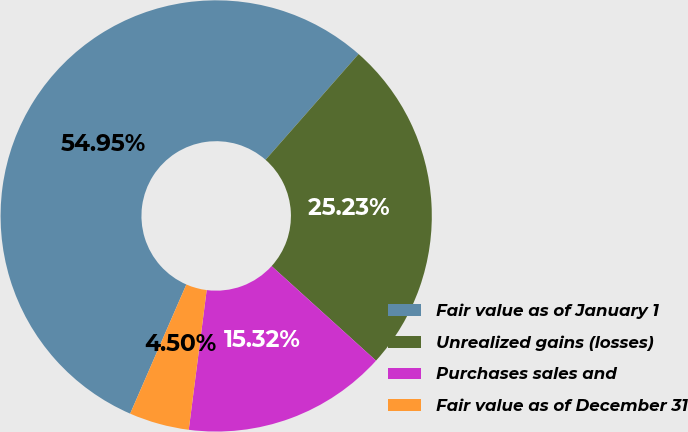<chart> <loc_0><loc_0><loc_500><loc_500><pie_chart><fcel>Fair value as of January 1<fcel>Unrealized gains (losses)<fcel>Purchases sales and<fcel>Fair value as of December 31<nl><fcel>54.95%<fcel>25.23%<fcel>15.32%<fcel>4.5%<nl></chart> 